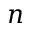<formula> <loc_0><loc_0><loc_500><loc_500>n</formula> 